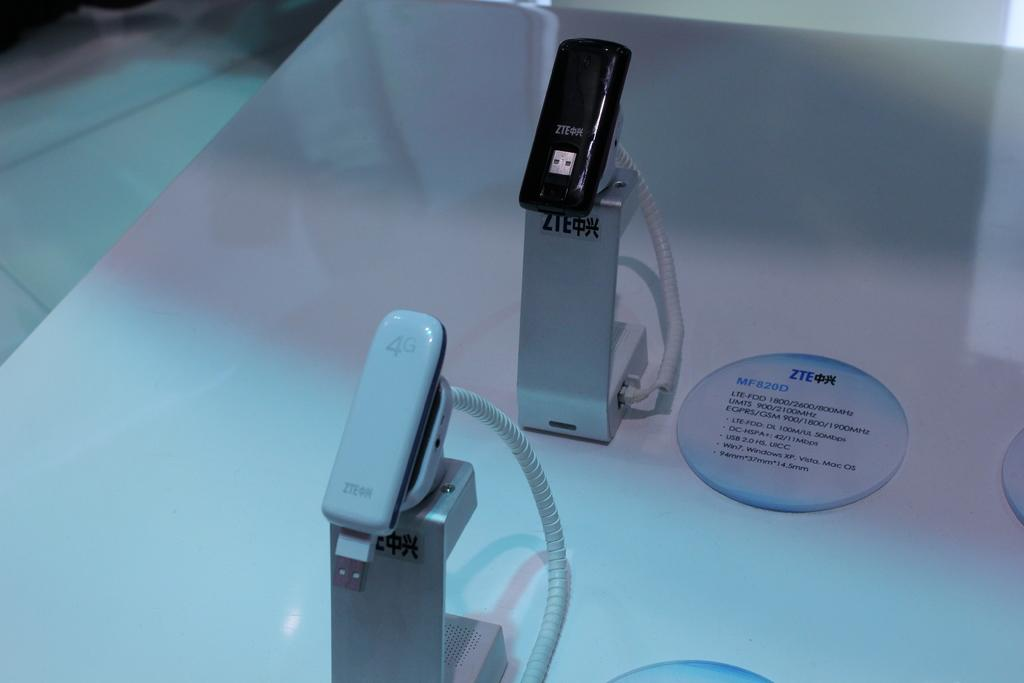Provide a one-sentence caption for the provided image. Above the white product is a black one and it is model number MF820D. 